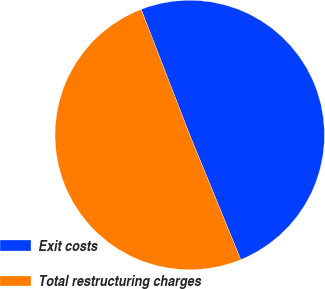Convert chart to OTSL. <chart><loc_0><loc_0><loc_500><loc_500><pie_chart><fcel>Exit costs<fcel>Total restructuring charges<nl><fcel>49.69%<fcel>50.31%<nl></chart> 